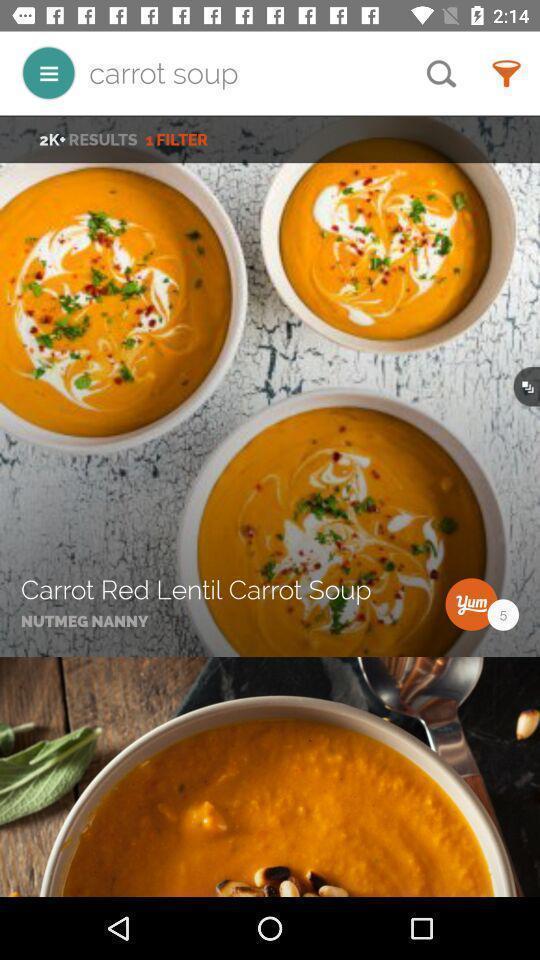What details can you identify in this image? Welcome page displaying of an food application. 